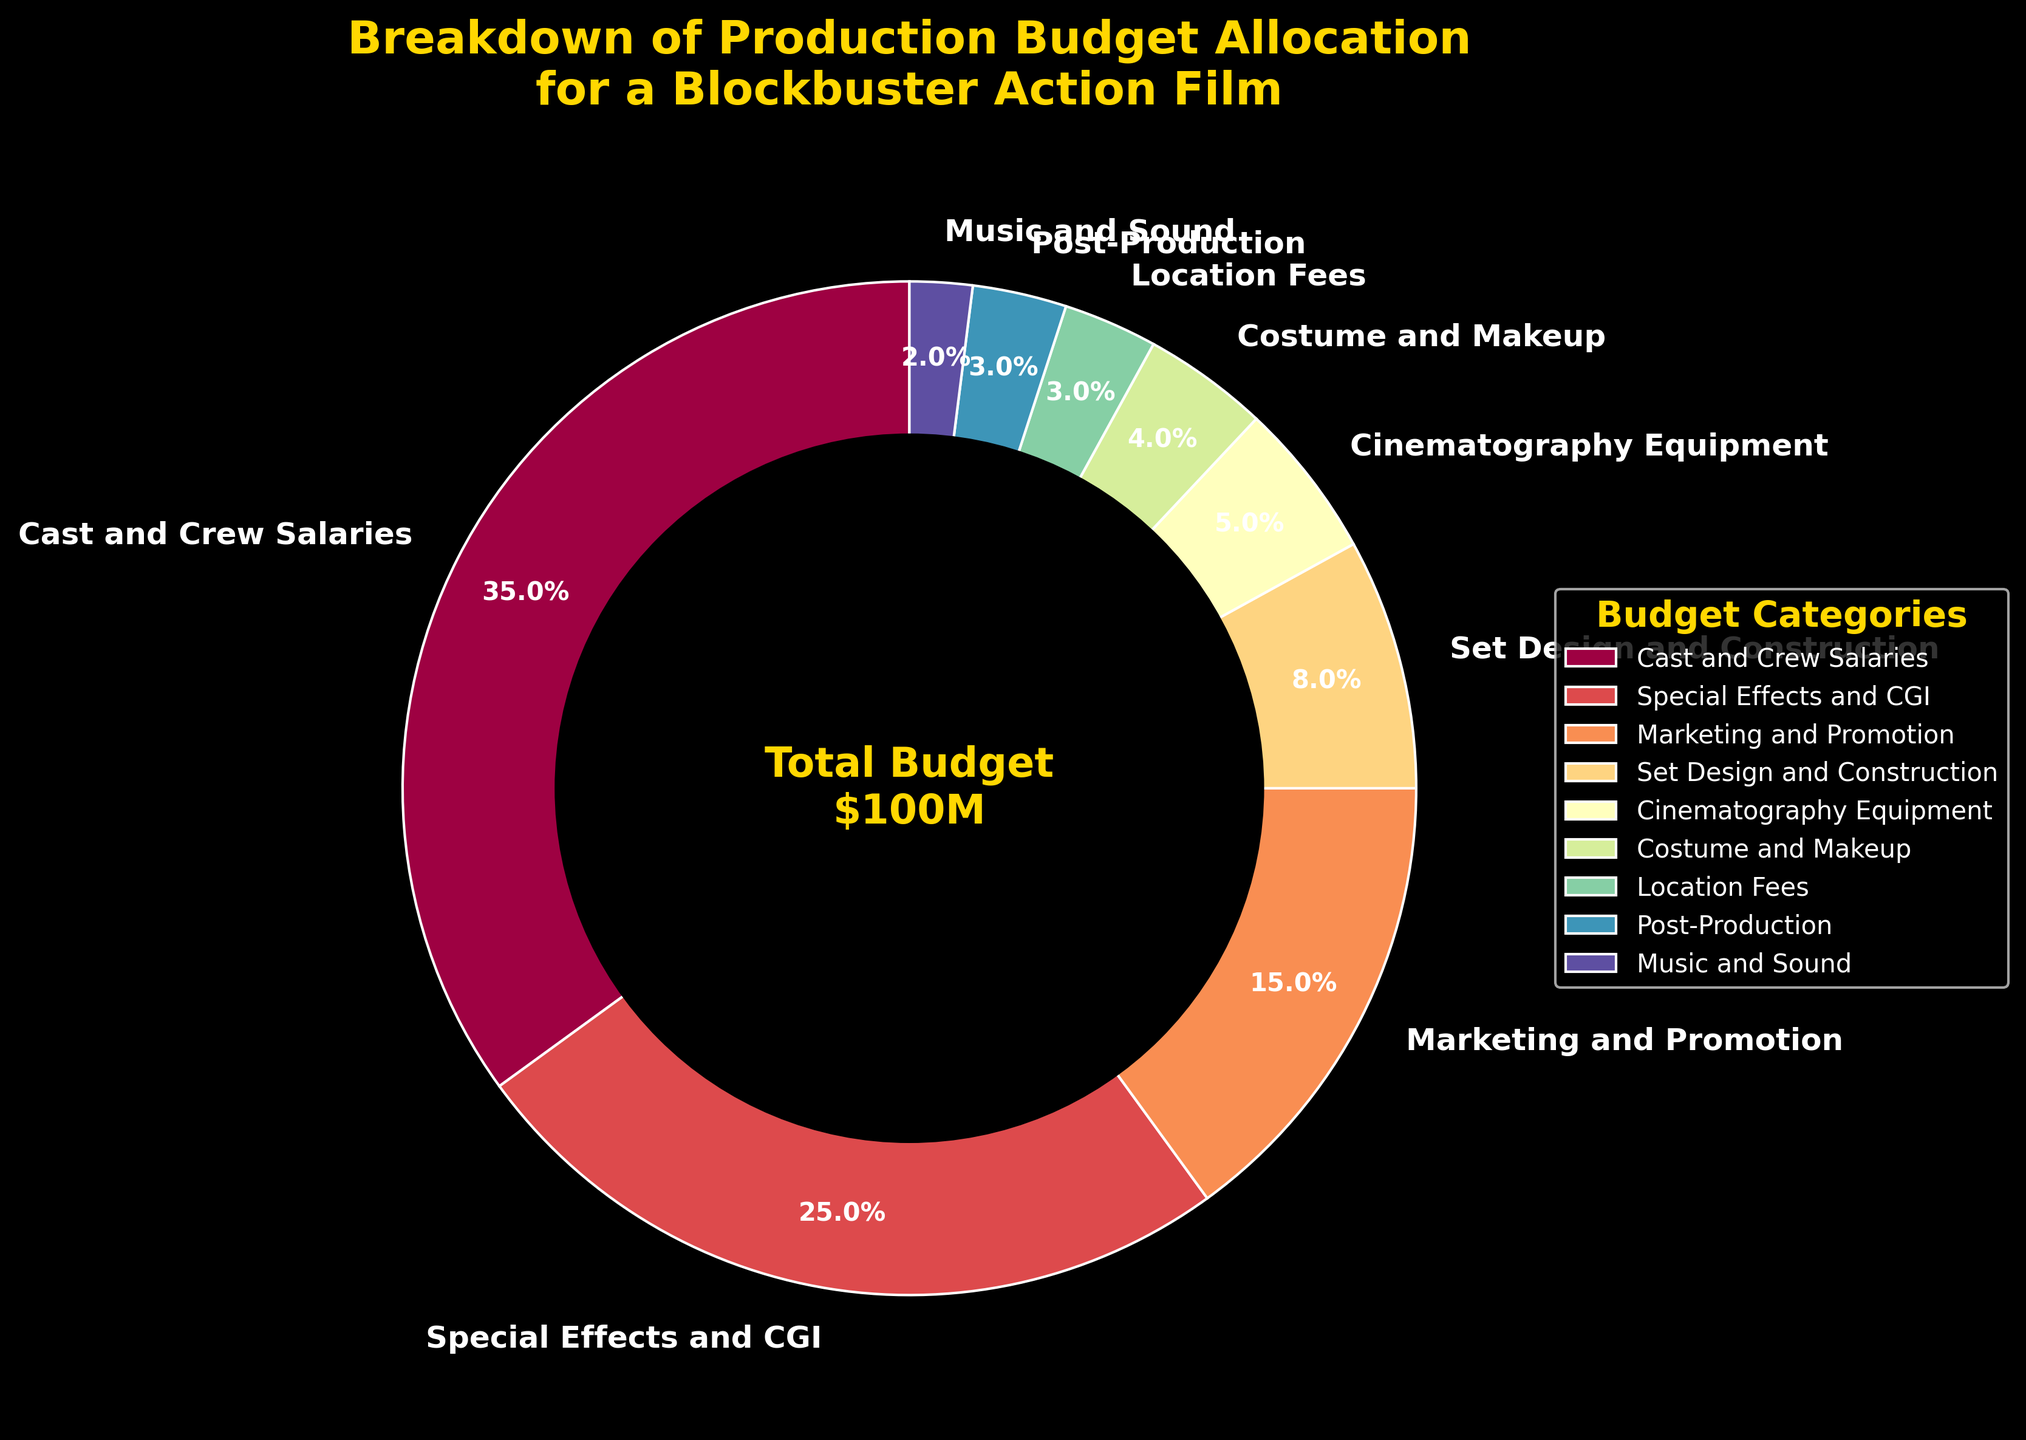What's the largest category in the budget allocation? The largest category can be identified by looking at the percentage values. Here, "Cast and Crew Salaries" has the highest value at 35%.
Answer: Cast and Crew Salaries Which category has a bigger budget allocation: Special Effects and CGI or Marketing and Promotion? Compare the percentage values of "Special Effects and CGI" (25%) and "Marketing and Promotion" (15%). Since 25% is greater than 15%, "Special Effects and CGI" has a bigger budget allocation.
Answer: Special Effects and CGI What percentage of the budget is allocated to Set Design and Construction and Cinematography Equipment combined? Add the percentage values of "Set Design and Construction" (8%) and "Cinematography Equipment" (5%). The combined total is 8% + 5% = 13%.
Answer: 13% How much more is allocated to Cast and Crew Salaries than Music and Sound? Subtract the percentage for "Music and Sound" (2%) from the percentage for "Cast and Crew Salaries" (35%). The difference is 35% - 2% = 33%.
Answer: 33% Is the budget allocated to Costume and Makeup greater than or equal to the sum of Location Fees and Music and Sound percentages? Sum the percentages of "Location Fees" (3%) and "Music and Sound" (2%) to get 3% + 2% = 5%. Compare this sum with "Costume and Makeup" which is 4%. Since 4% is less than 5%, the budget for Costume and Makeup is not greater than or equal to the combined budget of Location Fees and Music and Sound.
Answer: No Which category has the second smallest budget allocation? To find the second smallest allocation, first identify the smallest allocation which is "Music and Sound" at 2%. The next smallest allocation is "Post-Production" at 3%.
Answer: Post-Production What is the combined budget allocation for Marketing and Promotion, Set Design and Construction, and Costume and Makeup? Add the percentages for "Marketing and Promotion" (15%), "Set Design and Construction" (8%), and "Costume and Makeup" (4%). The total is 15% + 8% + 4% = 27%.
Answer: 27% How does the budget for Location Fees compare to the budget for Post-Production? Compare the percentages for "Location Fees" (3%) and "Post-Production" (3%). Both categories have equal budget allocation percentages.
Answer: Equal If the total budget is $100M, how much is allocated to Special Effects and CGI? Multiply the percentage for "Special Effects and CGI" (25%) by the total budget ($100M). The calculation is 0.25 * 100 = $25M.
Answer: $25M What visual element is used to emphasize the category labels in the pie chart? The category labels are emphasized using bold text in a dark background, making them stand out visually.
Answer: Bold text 